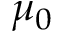<formula> <loc_0><loc_0><loc_500><loc_500>\mu _ { 0 }</formula> 